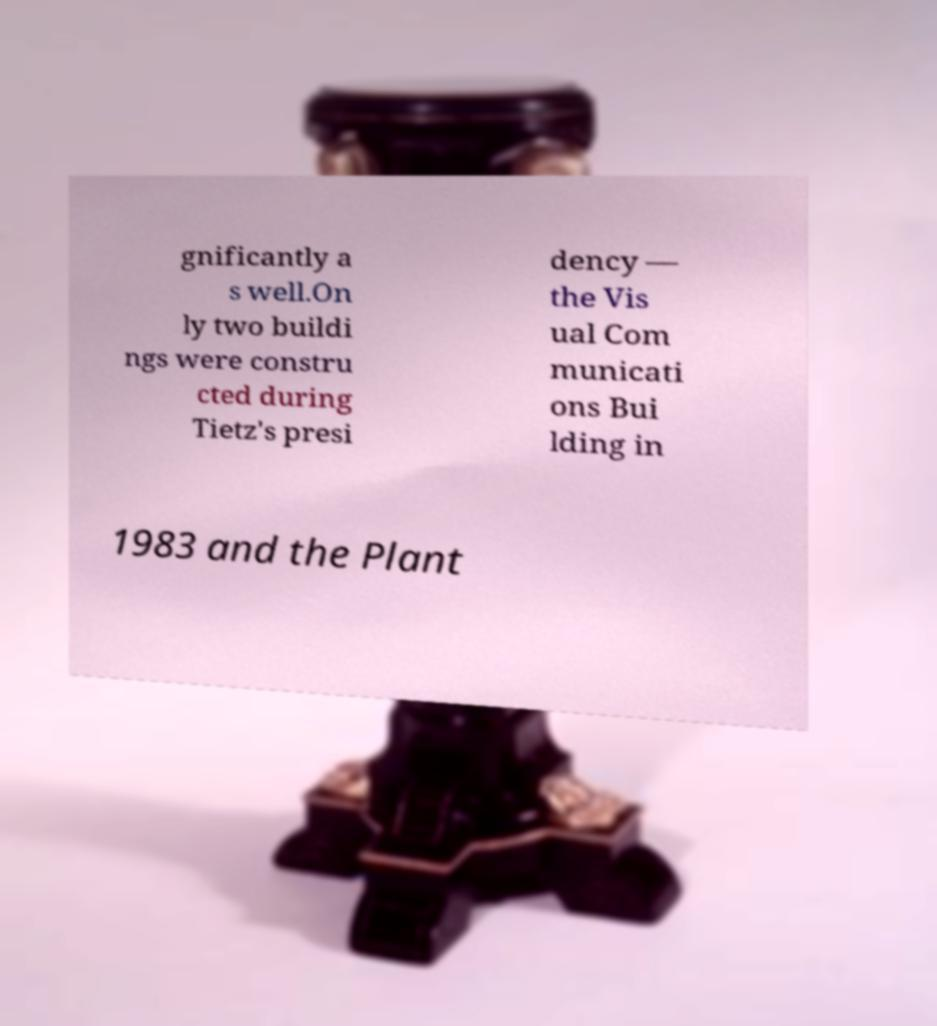For documentation purposes, I need the text within this image transcribed. Could you provide that? gnificantly a s well.On ly two buildi ngs were constru cted during Tietz's presi dency — the Vis ual Com municati ons Bui lding in 1983 and the Plant 